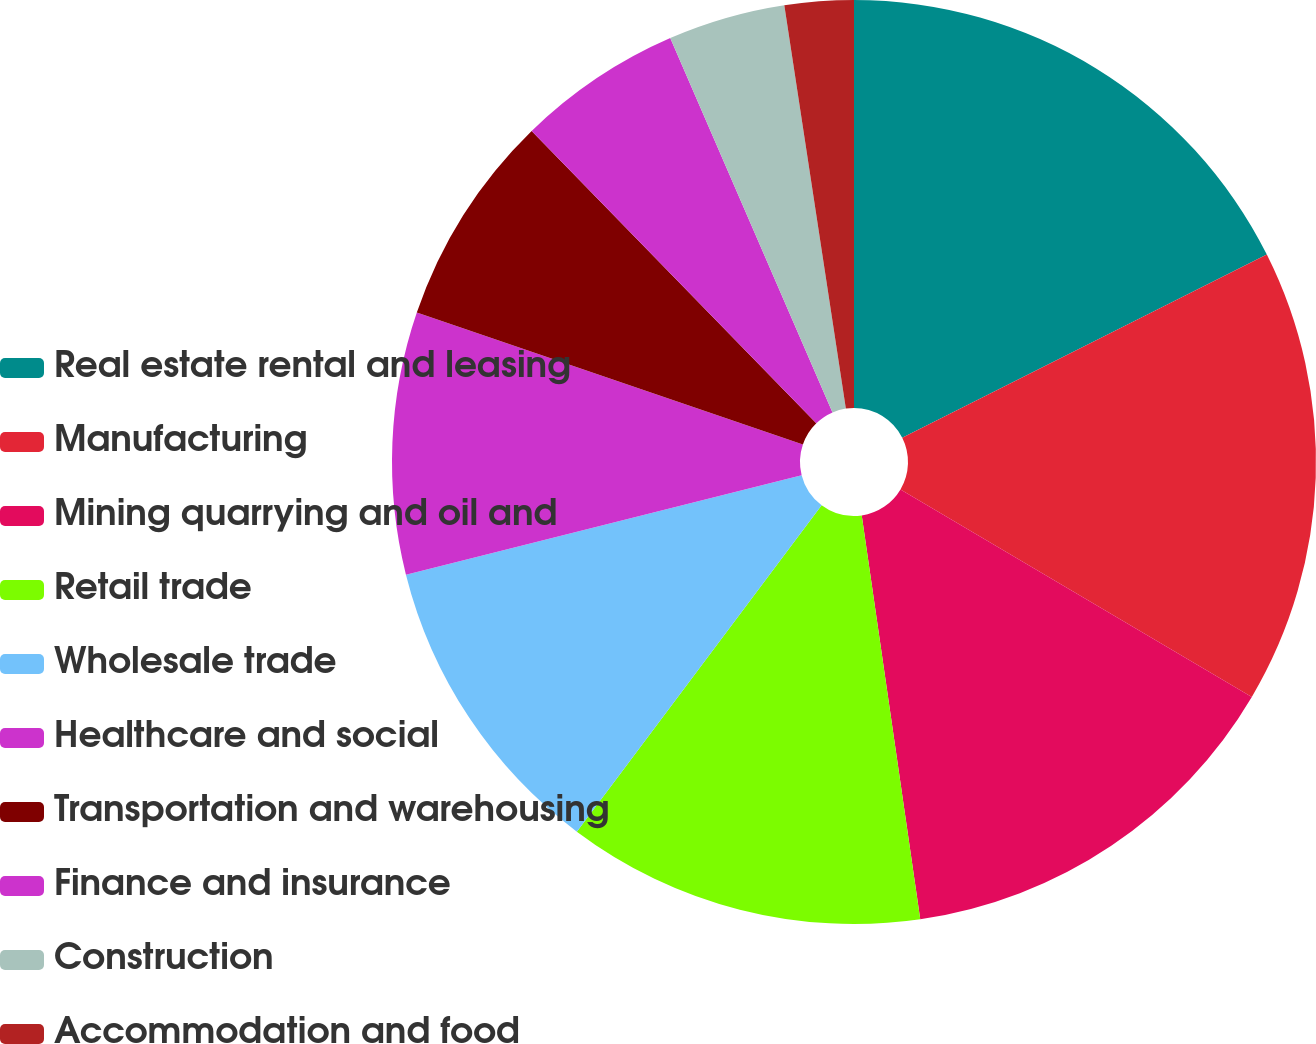<chart> <loc_0><loc_0><loc_500><loc_500><pie_chart><fcel>Real estate rental and leasing<fcel>Manufacturing<fcel>Mining quarrying and oil and<fcel>Retail trade<fcel>Wholesale trade<fcel>Healthcare and social<fcel>Transportation and warehousing<fcel>Finance and insurance<fcel>Construction<fcel>Accommodation and food<nl><fcel>17.59%<fcel>15.9%<fcel>14.22%<fcel>12.53%<fcel>10.84%<fcel>9.16%<fcel>7.47%<fcel>5.78%<fcel>4.1%<fcel>2.41%<nl></chart> 